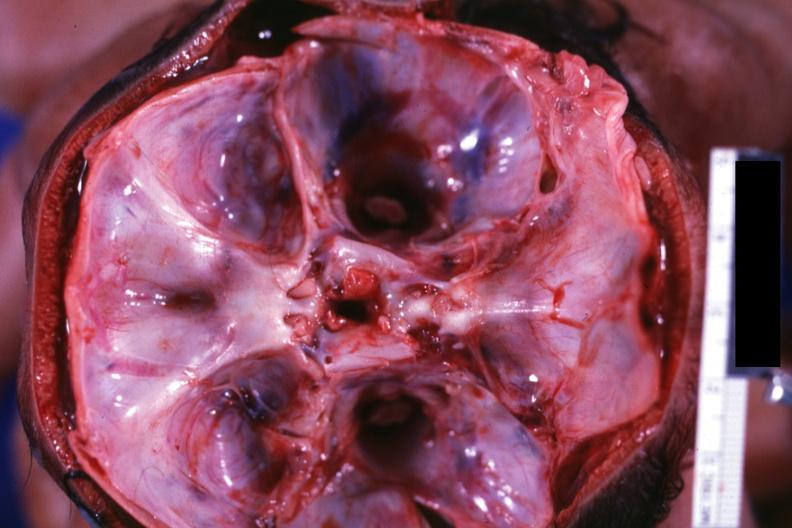what is present?
Answer the question using a single word or phrase. Bone, skull 